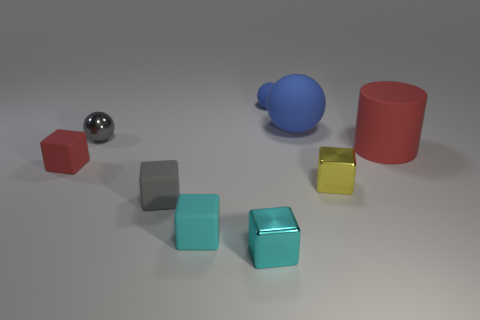The other ball that is the same color as the tiny matte sphere is what size?
Your answer should be very brief. Large. What number of other objects are the same size as the yellow cube?
Your answer should be compact. 6. What is the size of the object that is both in front of the red cube and to the right of the large sphere?
Make the answer very short. Small. Are there any big blue things that have the same material as the small red object?
Your response must be concise. Yes. What is the color of the tiny object that is both behind the small cyan rubber object and in front of the small yellow shiny cube?
Make the answer very short. Gray. What is the red thing that is on the left side of the tiny cyan rubber cube made of?
Keep it short and to the point. Rubber. Is there a gray rubber thing of the same shape as the small yellow metal thing?
Give a very brief answer. Yes. What number of other things are the same shape as the cyan shiny object?
Ensure brevity in your answer.  4. Do the cyan shiny thing and the red thing that is to the left of the small gray cube have the same shape?
Give a very brief answer. Yes. What is the material of the yellow object that is the same shape as the tiny cyan metallic object?
Provide a short and direct response. Metal. 